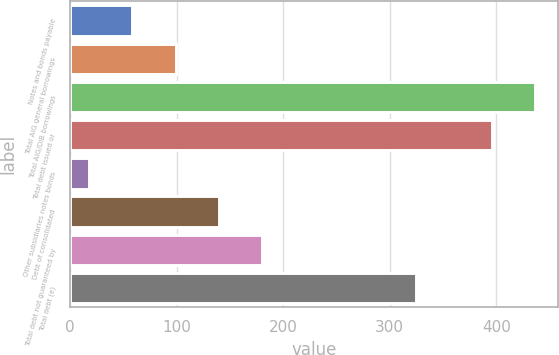<chart> <loc_0><loc_0><loc_500><loc_500><bar_chart><fcel>Notes and bonds payable<fcel>Total AIG general borrowings<fcel>Total AIG/DIB borrowings<fcel>Total debt issued or<fcel>Other subsidiaries notes bonds<fcel>Debt of consolidated<fcel>Total debt not guaranteed by<fcel>Total debt (e)<nl><fcel>58.5<fcel>99<fcel>436.5<fcel>396<fcel>18<fcel>139.5<fcel>180<fcel>325<nl></chart> 